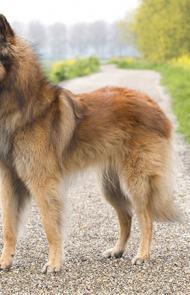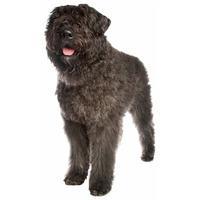The first image is the image on the left, the second image is the image on the right. Given the left and right images, does the statement "An image shows a german shepherd wearing a collar." hold true? Answer yes or no. No. 